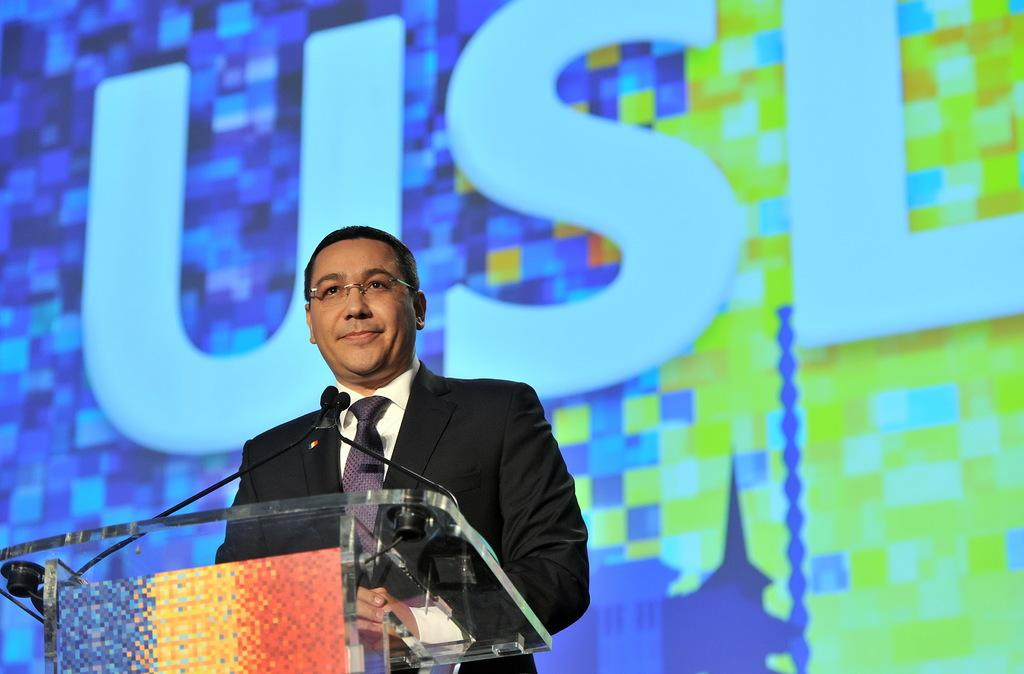What is the man in the image doing? The man is standing near the podium. What is on the podium? There are microphones on the podium. What can be seen in the background of the image? There is a board or a screen in the background. What type of metal is used to construct the rail in the image? There is no rail present in the image. 